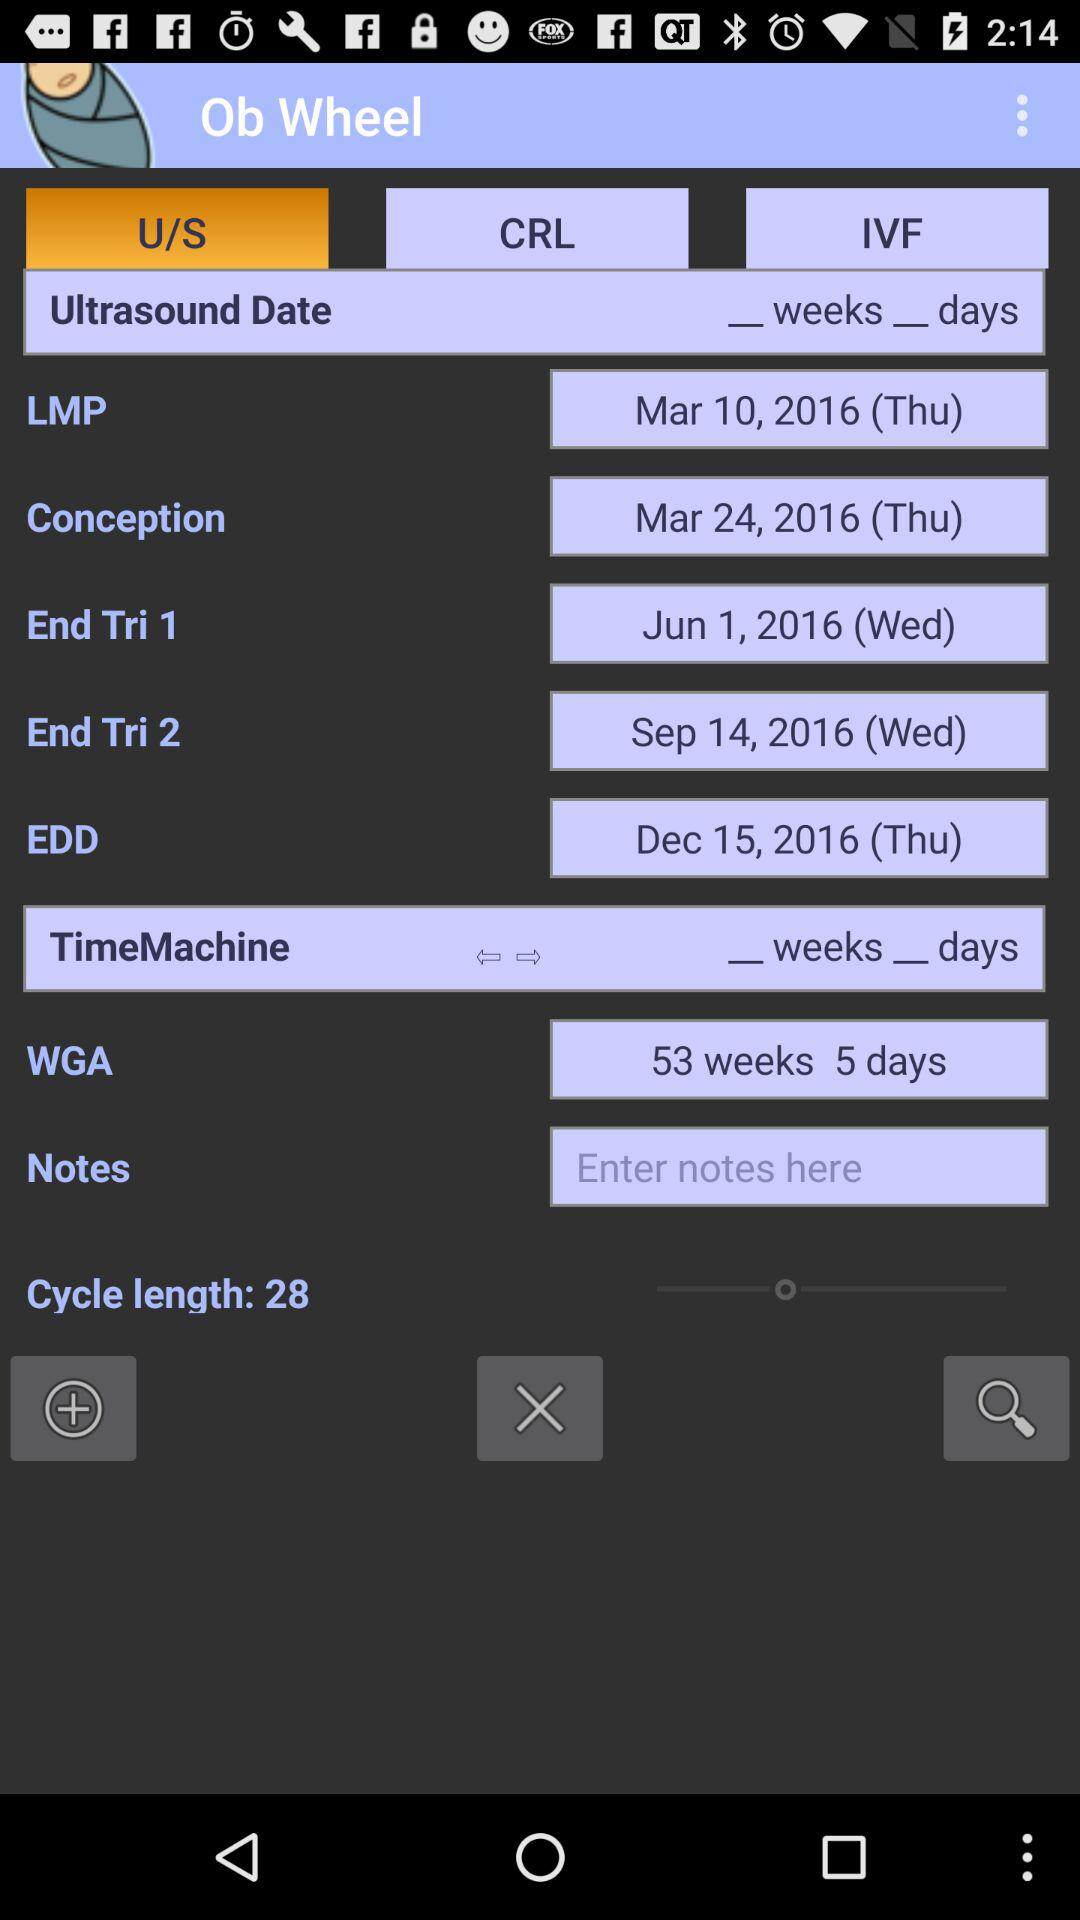On which date is "End Tri 1"? "End Tri 1" is on Wednesday, June 1, 2016. 